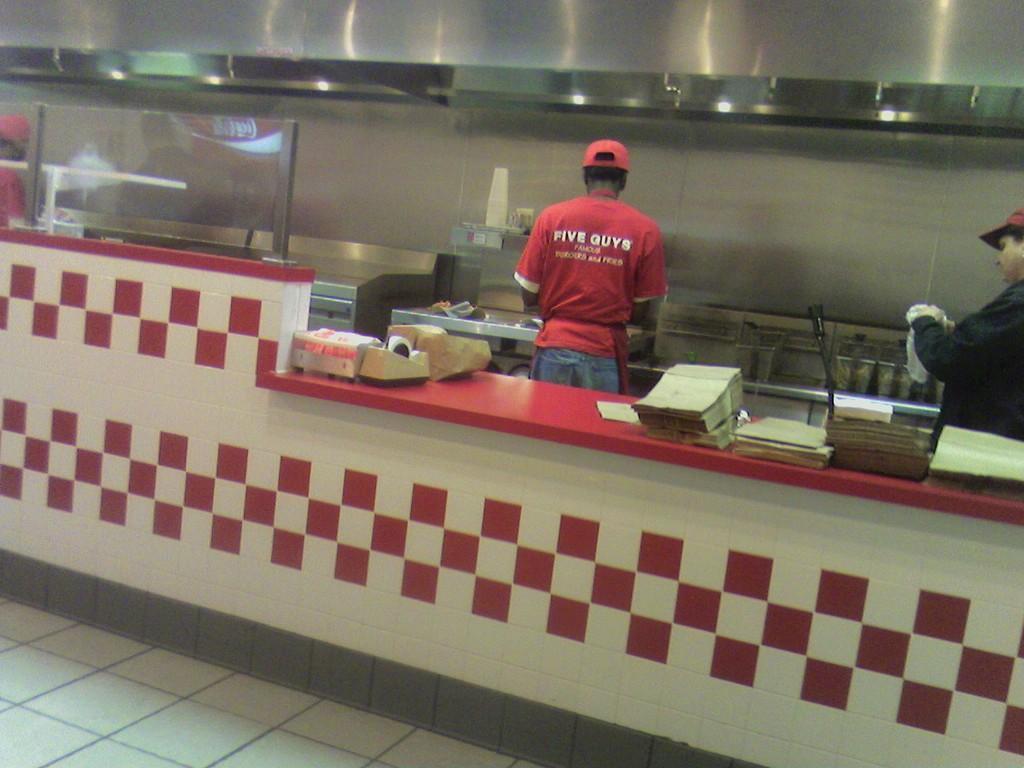In one or two sentences, can you explain what this image depicts? In this picture we can see inside view of the restaurant kitchen. In the front there is a white and red color cladding tiles a platform. Behind there is a chef wearing red color t-shirt, standing and preparing the food. Above there is a stainless steel big chimney. On the right corner you can see a man wearing black color dress, standing and cleaning the vessels. 